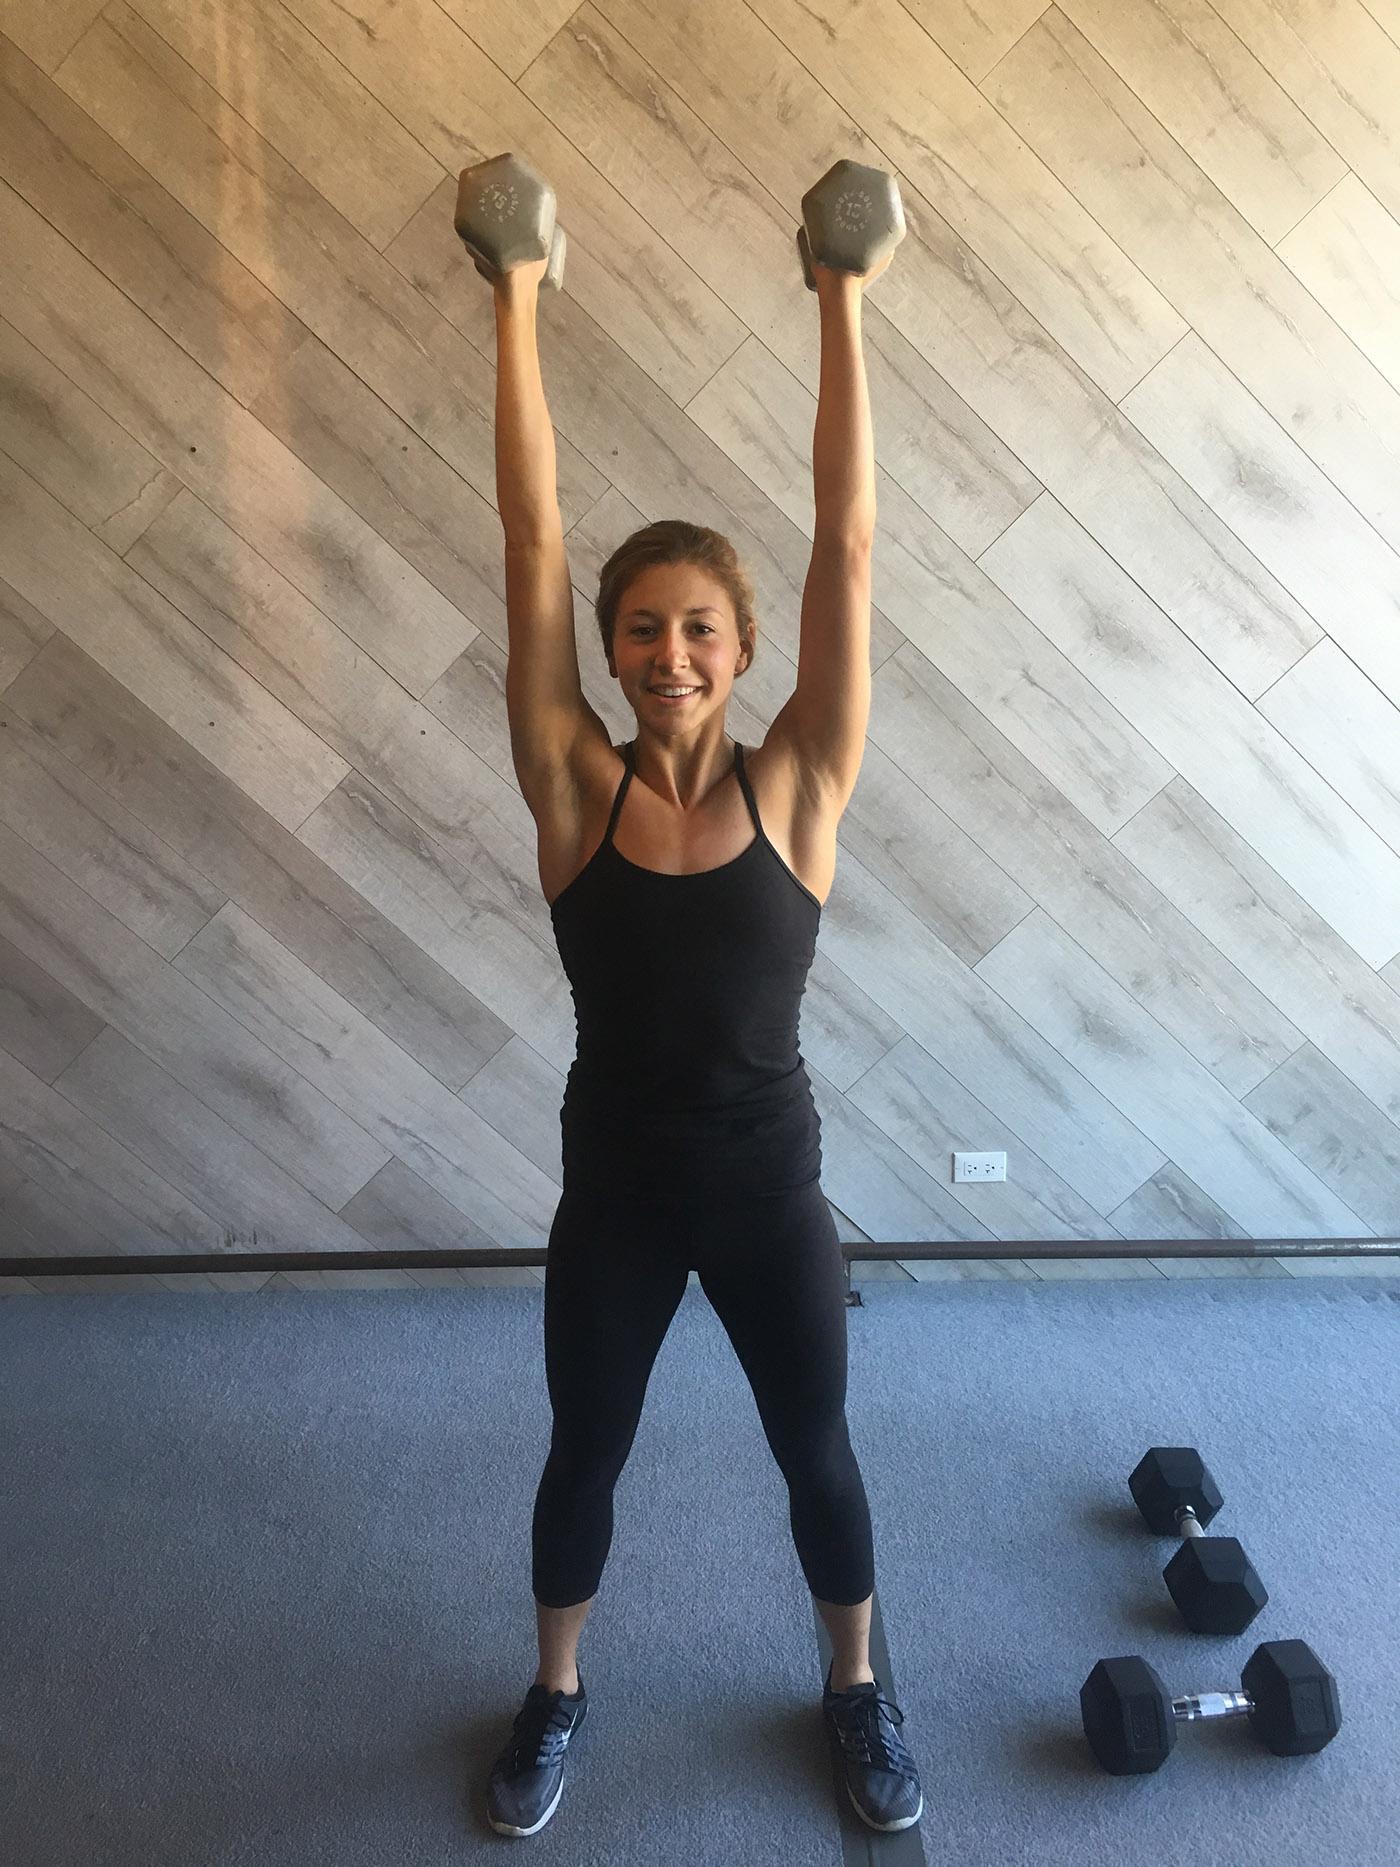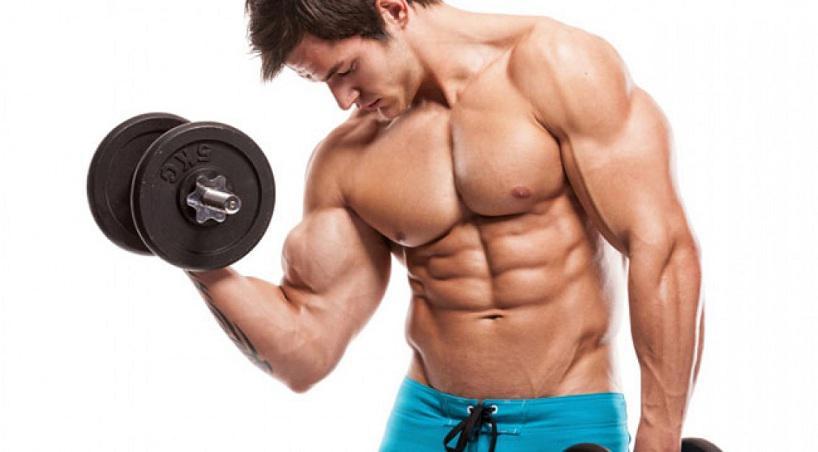The first image is the image on the left, the second image is the image on the right. For the images displayed, is the sentence "The person in the image on the left is lifting a single weight with one hand." factually correct? Answer yes or no. No. The first image is the image on the left, the second image is the image on the right. Assess this claim about the two images: "At least one athlete performing a dumbbell workout is a blonde woman in a purple tanktop.". Correct or not? Answer yes or no. No. 